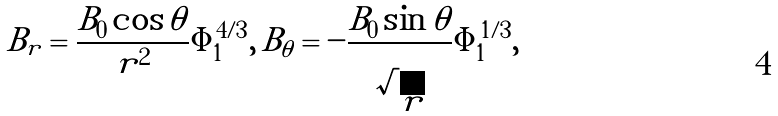Convert formula to latex. <formula><loc_0><loc_0><loc_500><loc_500>B _ { r } = \frac { B _ { 0 } \cos \theta } { r ^ { 2 } } \Phi _ { 1 } ^ { 4 / 3 } , \, B _ { \theta } = - \frac { B _ { 0 } \sin \theta } { \sqrt { r } } \Phi _ { 1 } ^ { 1 / 3 } ,</formula> 